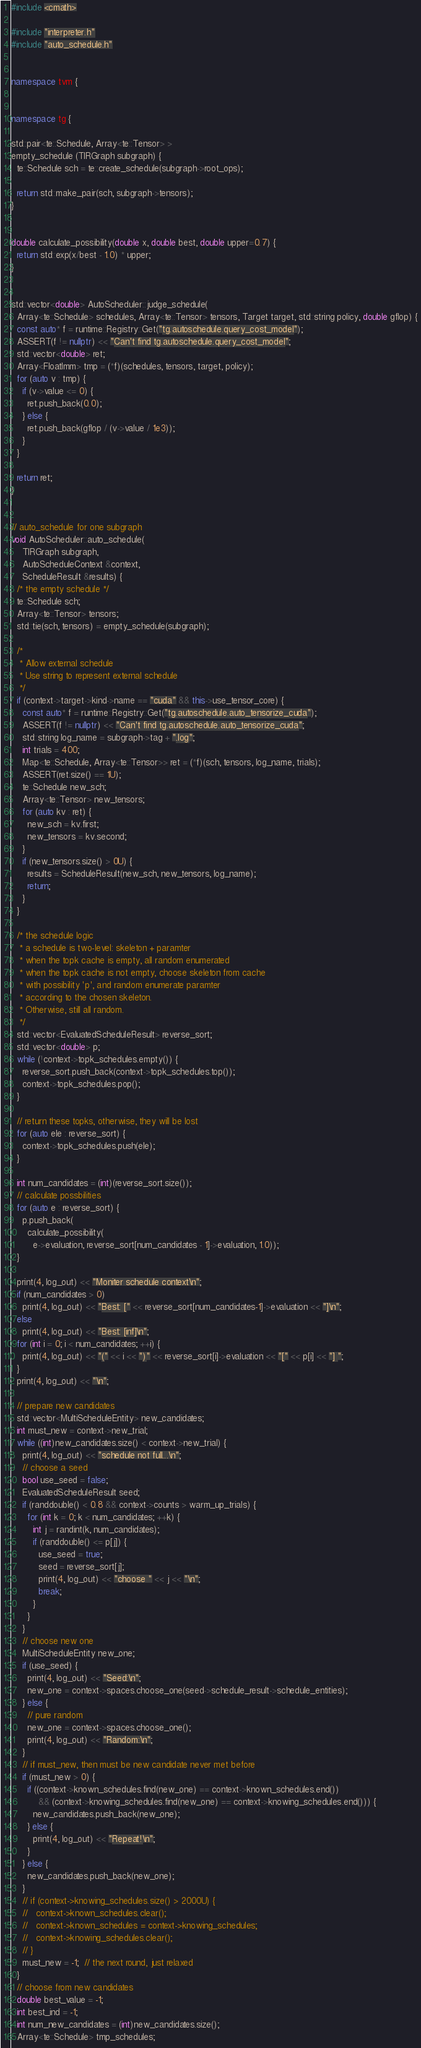Convert code to text. <code><loc_0><loc_0><loc_500><loc_500><_C++_>#include <cmath>

#include "interpreter.h"
#include "auto_schedule.h"


namespace tvm {


namespace tg {

std::pair<te::Schedule, Array<te::Tensor> >
empty_schedule (TIRGraph subgraph) {
  te::Schedule sch = te::create_schedule(subgraph->root_ops);

  return std::make_pair(sch, subgraph->tensors);
}


double calculate_possibility(double x, double best, double upper=0.7) {
  return std::exp(x/best - 1.0) * upper;
}


std::vector<double> AutoScheduler::judge_schedule(
  Array<te::Schedule> schedules, Array<te::Tensor> tensors, Target target, std::string policy, double gflop) {
  const auto* f = runtime::Registry::Get("tg.autoschedule.query_cost_model");
  ASSERT(f != nullptr) << "Can't find tg.autoschedule.query_cost_model";
  std::vector<double> ret;
  Array<FloatImm> tmp = (*f)(schedules, tensors, target, policy);
  for (auto v : tmp) {
    if (v->value <= 0) {
      ret.push_back(0.0);
    } else {
      ret.push_back(gflop / (v->value / 1e3));
    }
  }

  return ret;
}


// auto_schedule for one subgraph
void AutoScheduler::auto_schedule(
    TIRGraph subgraph,
    AutoScheduleContext &context,
    ScheduleResult &results) {
  /* the empty schedule */
  te::Schedule sch;
  Array<te::Tensor> tensors;
  std::tie(sch, tensors) = empty_schedule(subgraph);

  /*
   * Allow external schedule
   * Use string to represent external schedule
   */
  if (context->target->kind->name == "cuda" && this->use_tensor_core) {
    const auto* f = runtime::Registry::Get("tg.autoschedule.auto_tensorize_cuda");
    ASSERT(f != nullptr) << "Can't find tg.autoschedule.auto_tensorize_cuda";
    std::string log_name = subgraph->tag + ".log";
    int trials = 400;
    Map<te::Schedule, Array<te::Tensor>> ret = (*f)(sch, tensors, log_name, trials);
    ASSERT(ret.size() == 1U);
    te::Schedule new_sch;
    Array<te::Tensor> new_tensors;
    for (auto kv : ret) {
      new_sch = kv.first;
      new_tensors = kv.second;
    }
    if (new_tensors.size() > 0U) {
      results = ScheduleResult(new_sch, new_tensors, log_name);
      return;
    }
  }

  /* the schedule logic
   * a schedule is two-level: skeleton + paramter
   * when the topk cache is empty, all random enumerated
   * when the topk cache is not empty, choose skeleton from cache
   * with possibility 'p', and random enumerate paramter
   * according to the chosen skeleton.
   * Otherwise, still all random.
   */
  std::vector<EvaluatedScheduleResult> reverse_sort;
  std::vector<double> p;
  while (!context->topk_schedules.empty()) {
    reverse_sort.push_back(context->topk_schedules.top());
    context->topk_schedules.pop();
  }

  // return these topks, otherwise, they will be lost
  for (auto ele : reverse_sort) {
    context->topk_schedules.push(ele);
  }

  int num_candidates = (int)(reverse_sort.size());
  // calculate possbilities
  for (auto e : reverse_sort) {
    p.push_back(
      calculate_possibility(
        e->evaluation, reverse_sort[num_candidates - 1]->evaluation, 1.0));
  }

  print(4, log_out) << "Moniter schedule context\n";
  if (num_candidates > 0)
    print(4, log_out) << "Best: [" << reverse_sort[num_candidates-1]->evaluation << "]\n";
  else
    print(4, log_out) << "Best: [inf]\n";
  for (int i = 0; i < num_candidates; ++i) {
    print(4, log_out) << "(" << i << ")" << reverse_sort[i]->evaluation << "[" << p[i] << "] ";
  }
  print(4, log_out) << "\n";

  // prepare new candidates
  std::vector<MultiScheduleEntity> new_candidates;
  int must_new = context->new_trial;
  while ((int)new_candidates.size() < context->new_trial) {
    print(4, log_out) << "schedule not full...\n";
    // choose a seed
    bool use_seed = false;
    EvaluatedScheduleResult seed;
    if (randdouble() < 0.8 && context->counts > warm_up_trials) {
      for (int k = 0; k < num_candidates; ++k) {
        int j = randint(k, num_candidates);
        if (randdouble() <= p[j]) {
          use_seed = true;
          seed = reverse_sort[j];
          print(4, log_out) << "choose " << j << "\n";
          break;
        }
      }
    }
    // choose new one
    MultiScheduleEntity new_one;
    if (use_seed) {
      print(4, log_out) << "Seed:\n";
      new_one = context->spaces.choose_one(seed->schedule_result->schedule_entities);
    } else {
      // pure random
      new_one = context->spaces.choose_one();
      print(4, log_out) << "Random:\n";
    }
    // if must_new, then must be new candidate never met before
    if (must_new > 0) {
      if ((context->known_schedules.find(new_one) == context->known_schedules.end())
          && (context->knowing_schedules.find(new_one) == context->knowing_schedules.end())) {
        new_candidates.push_back(new_one);
      } else {
        print(4, log_out) << "Repeat!\n";
      }
    } else {
      new_candidates.push_back(new_one);
    }
    // if (context->knowing_schedules.size() > 2000U) {
    //   context->known_schedules.clear();
    //   context->known_schedules = context->knowing_schedules;
    //   context->knowing_schedules.clear();
    // }
    must_new = -1;  // the next round, just relaxed
  }
  // choose from new candidates
  double best_value = -1;
  int best_ind = -1;
  int num_new_candidates = (int)new_candidates.size();
  Array<te::Schedule> tmp_schedules;</code> 